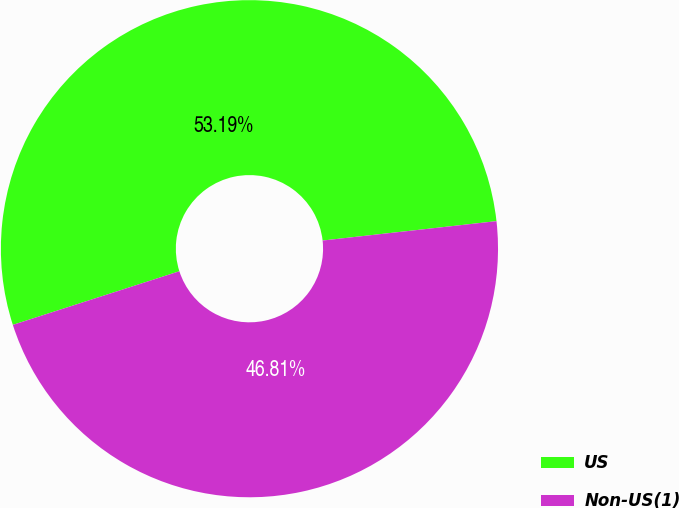Convert chart. <chart><loc_0><loc_0><loc_500><loc_500><pie_chart><fcel>US<fcel>Non-US(1)<nl><fcel>53.19%<fcel>46.81%<nl></chart> 